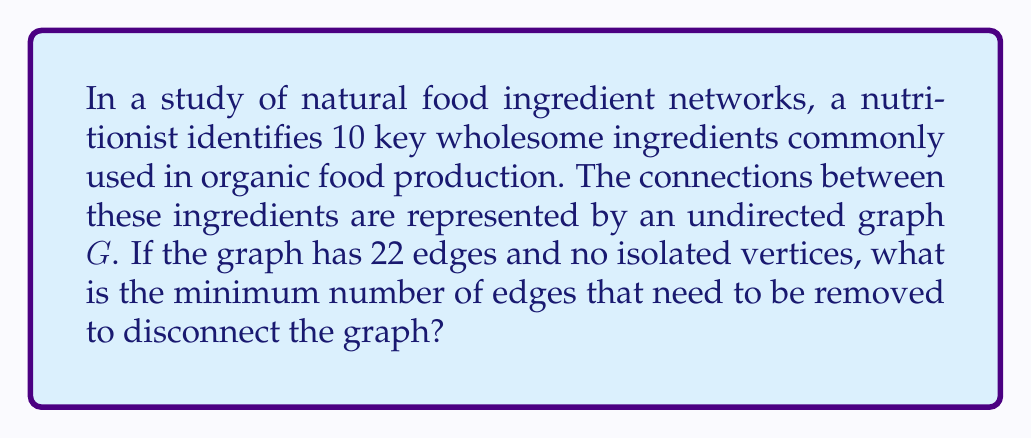Solve this math problem. To solve this problem, we need to understand the concept of graph connectivity and apply it to our food ingredient network. Let's approach this step-by-step:

1) First, recall that a graph with $n$ vertices is connected if and only if it has at least $n-1$ edges. This minimum number of edges forms a spanning tree of the graph.

2) In our case, we have $n = 10$ vertices (ingredients) and $m = 22$ edges (connections).

3) The minimum number of edges required for connectivity is $n-1 = 10-1 = 9$ edges.

4) The number of excess edges in our graph is:

   $m - (n-1) = 22 - 9 = 13$ edges

5) These excess edges create cycles in the graph. In topology, we define the cyclomatic number (or first Betti number) of a graph as:

   $\beta_1(G) = m - n + 1 = 22 - 10 + 1 = 13$

6) This number represents the maximum number of edges that can be removed while keeping the graph connected.

7) Therefore, to disconnect the graph, we need to remove at least one more edge than this number.

8) The minimum number of edges to remove to disconnect the graph is:

   $\beta_1(G) + 1 = 13 + 1 = 14$ edges

This means that even if we remove any 13 edges, the graph will still be connected by a spanning tree. Only by removing the 14th edge can we guarantee that the graph becomes disconnected.
Answer: The minimum number of edges that need to be removed to disconnect the graph is 14. 